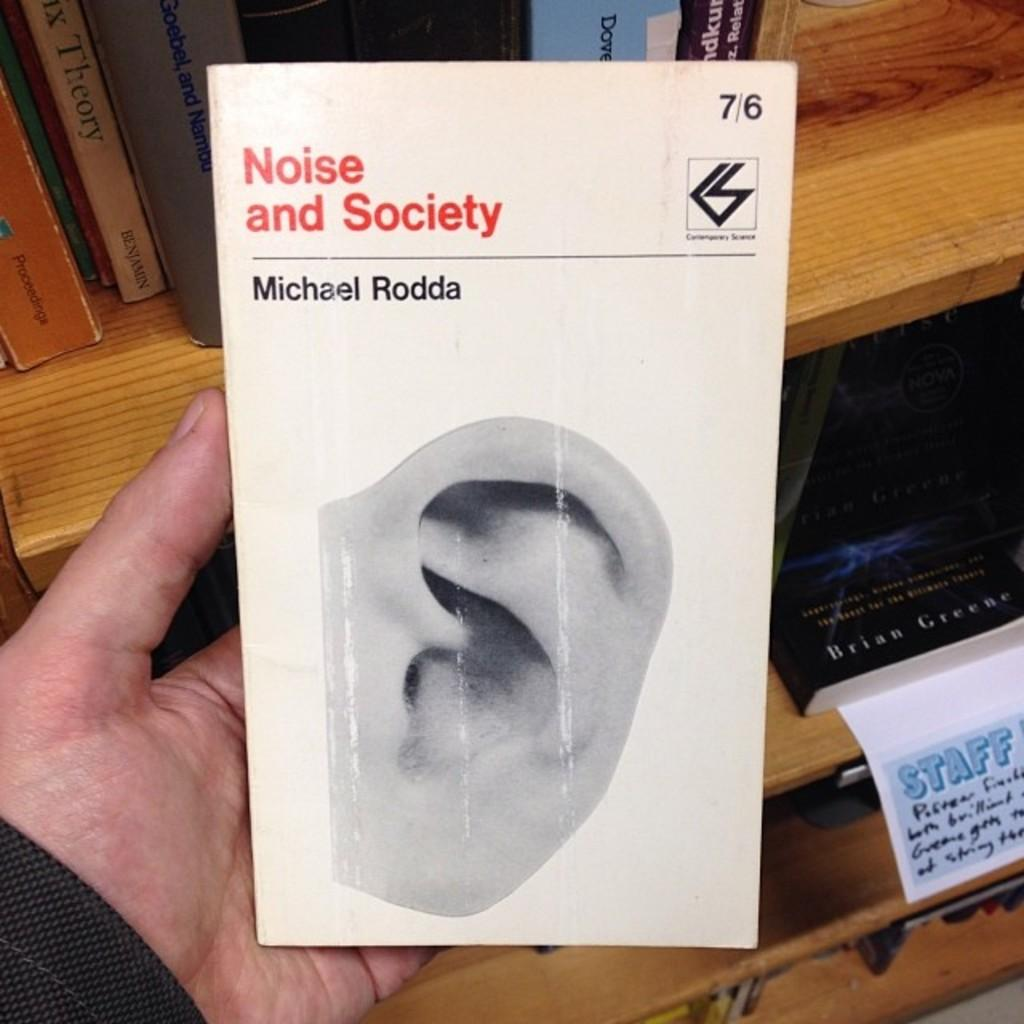<image>
Relay a brief, clear account of the picture shown. A person holding the paperback Noise and Society which has a white cover and a picture of an ear on it. 